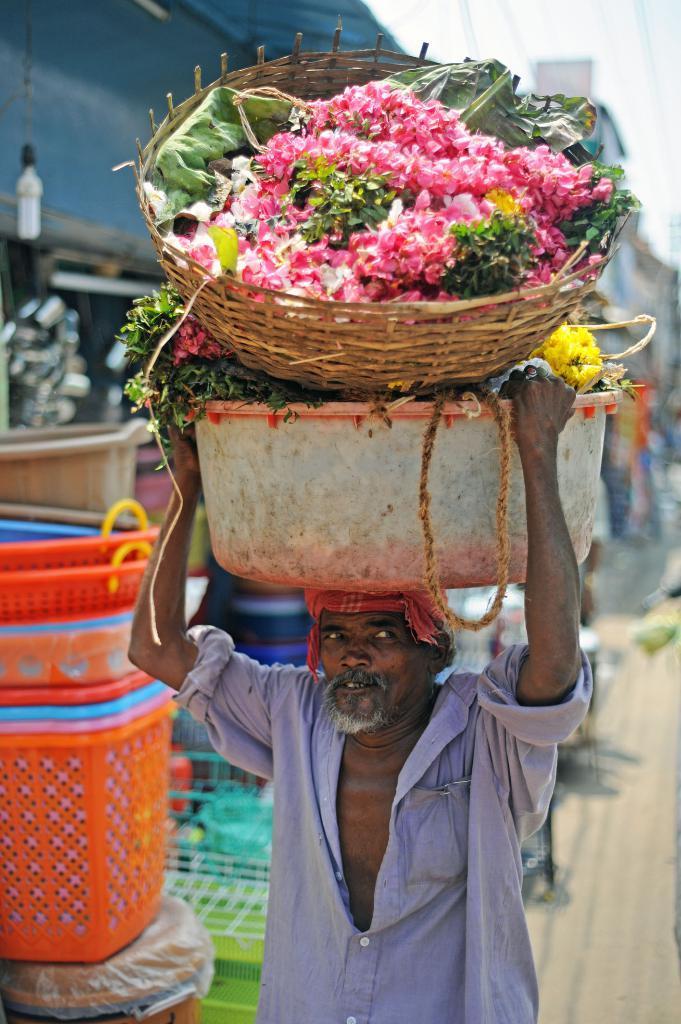Could you give a brief overview of what you see in this image? In the picture I can see a man is carrying flowers in wooden basket and some other objects on his head. In the background I can see baskets and other plastic objects. The background of the image is blurred. 